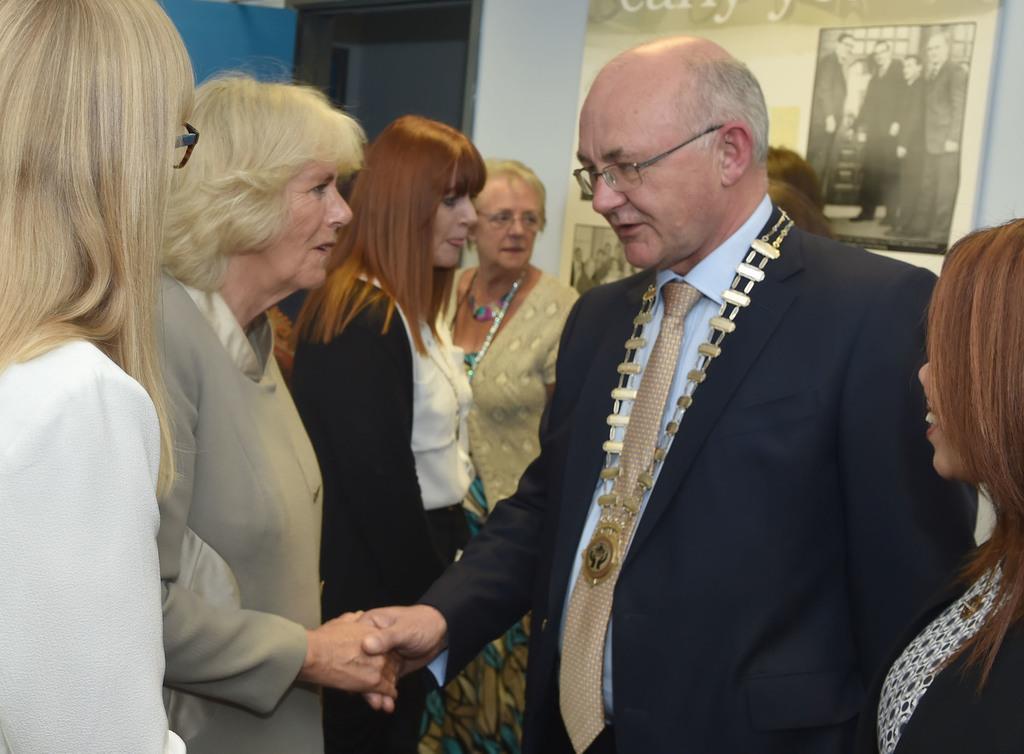Describe this image in one or two sentences. In this picture we can see few people are in one place, among them two persons are shaking their hands, behind we can see frame to the wall. 